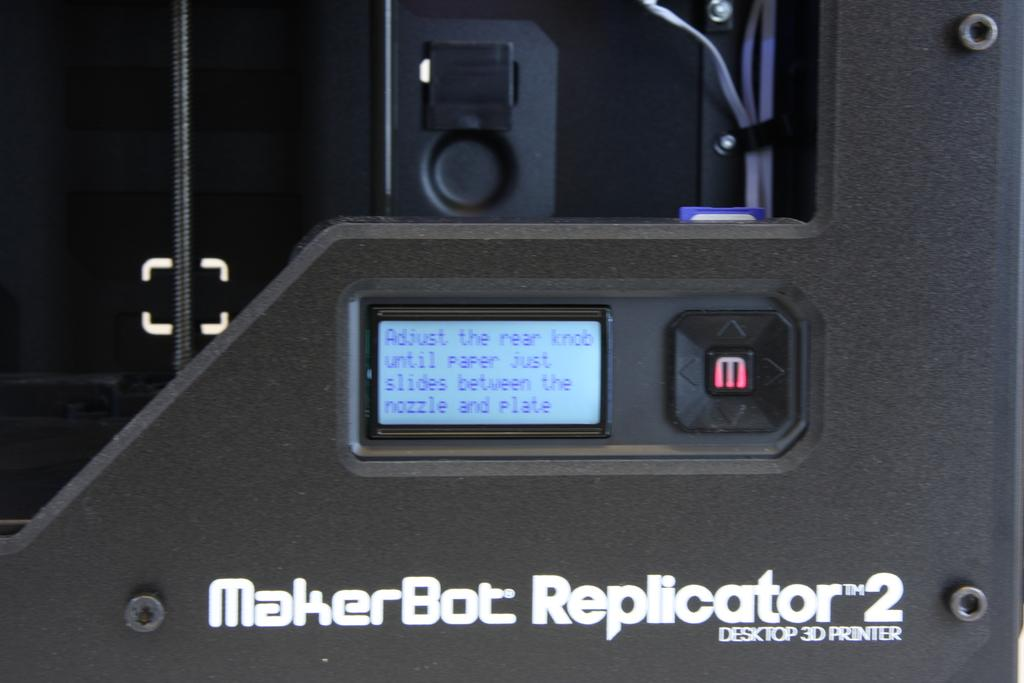What is the main object in the image? There is a machine in the image. What is displayed on the screen in the center of the image? There is a screen with text in the center of the image. What can be found in the center of the image besides the screen? There is a button in the center of the image. What type of fruit is placed on the desk in the image? There is no desk or fruit present in the image. How does the machine move around in the image? The machine does not move around in the image; it is stationary. 